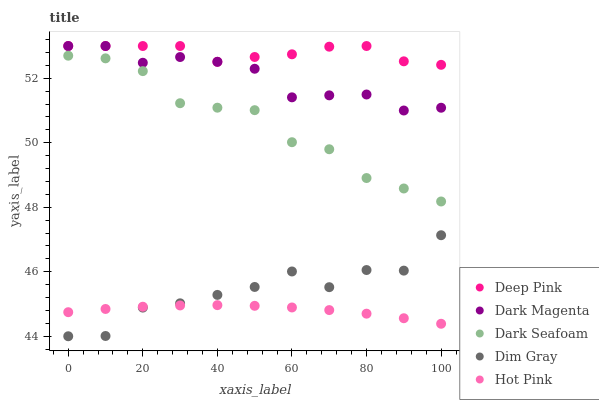Does Hot Pink have the minimum area under the curve?
Answer yes or no. Yes. Does Deep Pink have the maximum area under the curve?
Answer yes or no. Yes. Does Dark Magenta have the minimum area under the curve?
Answer yes or no. No. Does Dark Magenta have the maximum area under the curve?
Answer yes or no. No. Is Hot Pink the smoothest?
Answer yes or no. Yes. Is Dim Gray the roughest?
Answer yes or no. Yes. Is Deep Pink the smoothest?
Answer yes or no. No. Is Deep Pink the roughest?
Answer yes or no. No. Does Dim Gray have the lowest value?
Answer yes or no. Yes. Does Dark Magenta have the lowest value?
Answer yes or no. No. Does Dark Magenta have the highest value?
Answer yes or no. Yes. Does Dim Gray have the highest value?
Answer yes or no. No. Is Dim Gray less than Deep Pink?
Answer yes or no. Yes. Is Dark Magenta greater than Hot Pink?
Answer yes or no. Yes. Does Deep Pink intersect Dark Magenta?
Answer yes or no. Yes. Is Deep Pink less than Dark Magenta?
Answer yes or no. No. Is Deep Pink greater than Dark Magenta?
Answer yes or no. No. Does Dim Gray intersect Deep Pink?
Answer yes or no. No. 